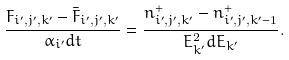Convert formula to latex. <formula><loc_0><loc_0><loc_500><loc_500>\frac { F _ { i ^ { \prime } , j ^ { \prime } , k ^ { \prime } } - \bar { F } _ { i ^ { \prime } , j ^ { \prime } , k ^ { \prime } } } { \alpha _ { i ^ { \prime } } d t } = \frac { n ^ { + } _ { i ^ { \prime } , j ^ { \prime } , k ^ { \prime } } - n ^ { + } _ { i ^ { \prime } , j ^ { \prime } , k ^ { \prime } - 1 } } { E _ { k ^ { \prime } } ^ { 2 } d E _ { k ^ { \prime } } } .</formula> 